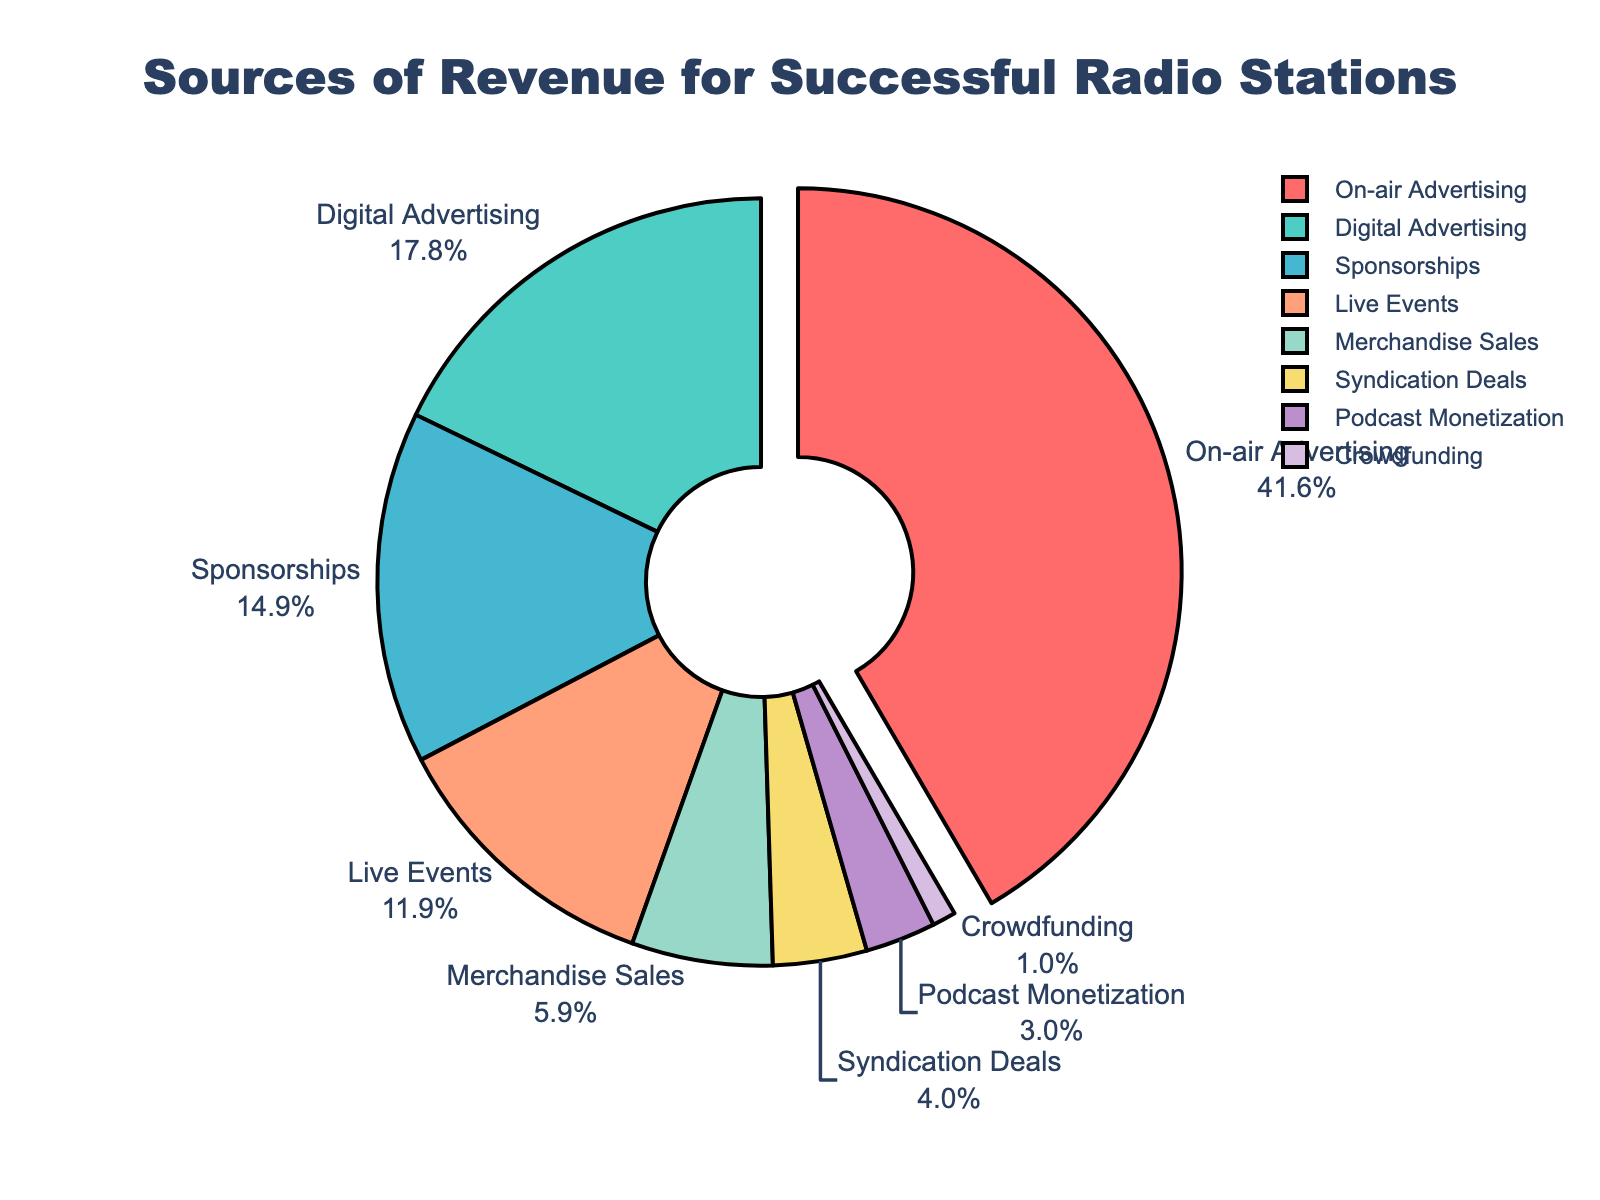What is the largest source of revenue for successful radio stations? The largest source of revenue can be identified as the segment that occupies the most space and is pulled out slightly from the pie for emphasis. The label indicates that On-air Advertising is responsible for 42% of the revenue.
Answer: On-air Advertising How much more revenue does On-air Advertising generate compared to Digital Advertising? Subtract the percentage of Digital Advertising from On-air Advertising. On-air Advertising generates 42% and Digital Advertising generates 18%. So, the difference is 42% - 18% = 24%.
Answer: 24% What percentage of revenue comes from live events, merchandise sales, and crowdfunding combined? Add the percentages for Live Events, Merchandise Sales, and Crowdfunding. Live Events is 12%, Merchandise Sales is 6%, and Crowdfunding is 1%. So, 12% + 6% + 1% = 19%.
Answer: 19% Which revenue source generates the least income? The smallest segment of the pie chart represents the least income. The label shows Crowdfunding at 1%.
Answer: Crowdfunding Can you rank the sources of revenue from highest to lowest? Arrange the segments in descending order based on their percentages. The order is: On-air Advertising (42%), Digital Advertising (18%), Sponsorships (15%), Live Events (12%), Merchandise Sales (6%), Syndication Deals (4%), Podcast Monetization (3%), Crowdfunding (1%).
Answer: On-air Advertising, Digital Advertising, Sponsorships, Live Events, Merchandise Sales, Syndication Deals, Podcast Monetization, Crowdfunding How many more times revenue does On-air Advertising generate compared to Podcast Monetization? Divide the percentage of On-air Advertising by that of Podcast Monetization. On-air Advertising is 42% and Podcast Monetization is 3%. So, 42% / 3% = 14 times.
Answer: 14 times Which revenue sources together make up more than half of the total revenue? Combine the percentages sequentially until the sum exceeds 50%. On-air Advertising (42%) and Digital Advertising (18%) together make 42% + 18% = 60%, which is more than half.
Answer: On-air Advertising, Digital Advertising How does the revenue from Sponsorships compare to Live Events? Sponsorships have a segment indicating 15%, and Live Events have a segment indicating 12%. Since 15% is greater than 12%, Sponsorships generate more revenue than Live Events.
Answer: Sponsorships generate more What is the combined revenue percentage of the sources that generate less than 10% individually? Identify the sources with less than 10% and add their percentages. The sources are Merchandise Sales (6%), Syndication Deals (4%), Podcast Monetization (3%), and Crowdfunding (1%). Adding them, 6% + 4% + 3% + 1% = 14%.
Answer: 14% What is the average percentage contribution of all revenue sources? Add all the percentages and then divide by the number of sources. (42+18+15+12+6+4+3+1)% = 101%. There are 8 sources. So, 101% / 8 = 12.625%.
Answer: 12.625% 